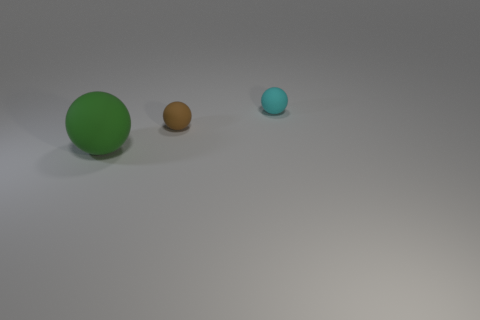Subtract all brown spheres. How many spheres are left? 2 Add 3 large gray things. How many objects exist? 6 Subtract all large green balls. Subtract all tiny brown things. How many objects are left? 1 Add 1 brown matte objects. How many brown matte objects are left? 2 Add 2 big matte objects. How many big matte objects exist? 3 Subtract 1 brown balls. How many objects are left? 2 